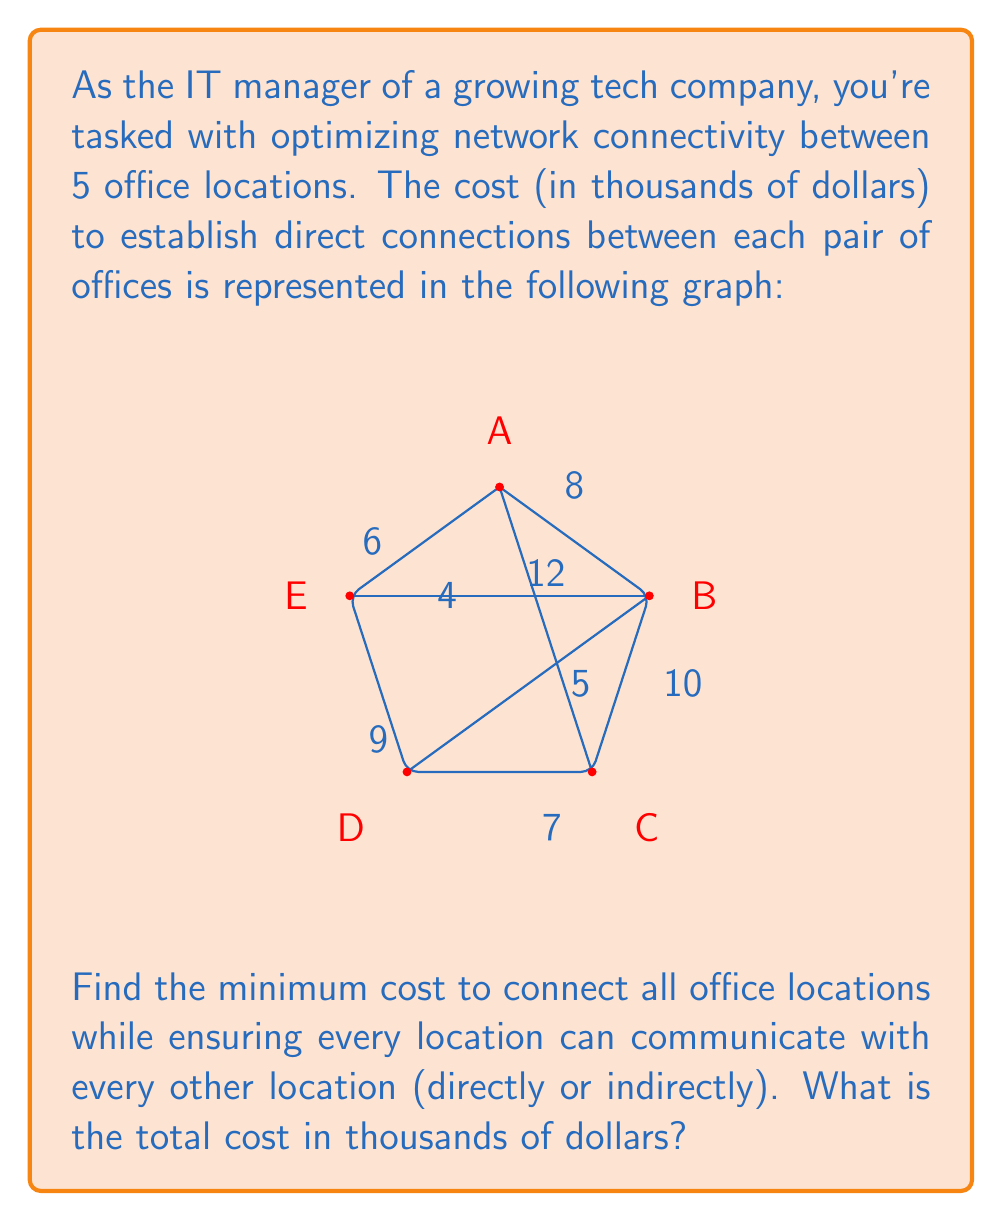Show me your answer to this math problem. To solve this problem, we need to find the Minimum Spanning Tree (MST) of the given graph. The MST will connect all offices with the minimum total cost while ensuring all locations can communicate.

We can use Kruskal's algorithm to find the MST:

1. Sort all edges by weight (cost) in ascending order:
   BE (4), BD (5), EA (6), CD (7), AB (8), DE (9), BC (10), AC (12)

2. Start with an empty set of edges and add edges one by one, skipping any that would create a cycle:

   - Add BE (4)
   - Add BD (5)
   - Add EA (6)
   - Add CD (7)
   - Skip AB (8) as it would create a cycle
   - Skip DE (9) as it would create a cycle
   - Skip BC (10) as it would create a cycle
   - Skip AC (12) as it would create a cycle

3. The resulting MST consists of the edges: BE, BD, EA, and CD.

4. Calculate the total cost:
   $$ \text{Total Cost} = 4 + 5 + 6 + 7 = 22 $$

Therefore, the minimum cost to connect all office locations is 22 thousand dollars.
Answer: $22,000 